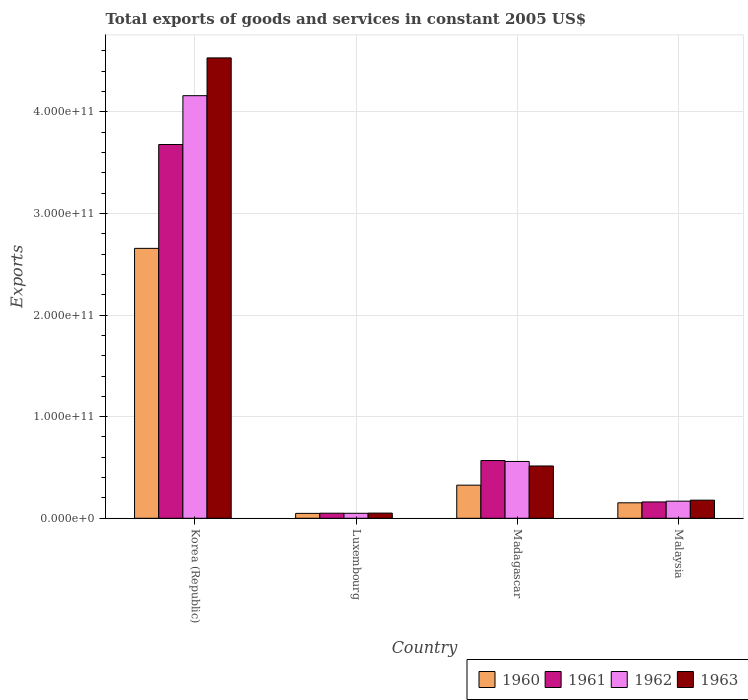How many groups of bars are there?
Provide a short and direct response. 4. Are the number of bars per tick equal to the number of legend labels?
Ensure brevity in your answer.  Yes. How many bars are there on the 1st tick from the right?
Keep it short and to the point. 4. In how many cases, is the number of bars for a given country not equal to the number of legend labels?
Give a very brief answer. 0. What is the total exports of goods and services in 1963 in Malaysia?
Provide a succinct answer. 1.78e+1. Across all countries, what is the maximum total exports of goods and services in 1961?
Make the answer very short. 3.68e+11. Across all countries, what is the minimum total exports of goods and services in 1962?
Ensure brevity in your answer.  4.90e+09. In which country was the total exports of goods and services in 1963 maximum?
Offer a very short reply. Korea (Republic). In which country was the total exports of goods and services in 1963 minimum?
Give a very brief answer. Luxembourg. What is the total total exports of goods and services in 1961 in the graph?
Your answer should be very brief. 4.46e+11. What is the difference between the total exports of goods and services in 1963 in Korea (Republic) and that in Madagascar?
Provide a short and direct response. 4.02e+11. What is the difference between the total exports of goods and services in 1961 in Madagascar and the total exports of goods and services in 1963 in Malaysia?
Keep it short and to the point. 3.90e+1. What is the average total exports of goods and services in 1963 per country?
Ensure brevity in your answer.  1.32e+11. What is the difference between the total exports of goods and services of/in 1962 and total exports of goods and services of/in 1960 in Luxembourg?
Provide a succinct answer. 8.82e+07. What is the ratio of the total exports of goods and services in 1963 in Korea (Republic) to that in Madagascar?
Offer a very short reply. 8.8. Is the total exports of goods and services in 1963 in Madagascar less than that in Malaysia?
Make the answer very short. No. Is the difference between the total exports of goods and services in 1962 in Madagascar and Malaysia greater than the difference between the total exports of goods and services in 1960 in Madagascar and Malaysia?
Your answer should be compact. Yes. What is the difference between the highest and the second highest total exports of goods and services in 1960?
Give a very brief answer. 2.50e+11. What is the difference between the highest and the lowest total exports of goods and services in 1961?
Make the answer very short. 3.63e+11. In how many countries, is the total exports of goods and services in 1960 greater than the average total exports of goods and services in 1960 taken over all countries?
Offer a very short reply. 1. Is the sum of the total exports of goods and services in 1962 in Madagascar and Malaysia greater than the maximum total exports of goods and services in 1963 across all countries?
Give a very brief answer. No. Is it the case that in every country, the sum of the total exports of goods and services in 1960 and total exports of goods and services in 1961 is greater than the sum of total exports of goods and services in 1963 and total exports of goods and services in 1962?
Make the answer very short. No. What does the 4th bar from the left in Luxembourg represents?
Provide a short and direct response. 1963. Are all the bars in the graph horizontal?
Provide a succinct answer. No. What is the difference between two consecutive major ticks on the Y-axis?
Offer a terse response. 1.00e+11. Does the graph contain any zero values?
Give a very brief answer. No. Does the graph contain grids?
Provide a succinct answer. Yes. What is the title of the graph?
Offer a terse response. Total exports of goods and services in constant 2005 US$. What is the label or title of the X-axis?
Your response must be concise. Country. What is the label or title of the Y-axis?
Keep it short and to the point. Exports. What is the Exports of 1960 in Korea (Republic)?
Your response must be concise. 2.66e+11. What is the Exports of 1961 in Korea (Republic)?
Offer a very short reply. 3.68e+11. What is the Exports in 1962 in Korea (Republic)?
Provide a short and direct response. 4.16e+11. What is the Exports of 1963 in Korea (Republic)?
Ensure brevity in your answer.  4.53e+11. What is the Exports of 1960 in Luxembourg?
Ensure brevity in your answer.  4.81e+09. What is the Exports of 1961 in Luxembourg?
Your answer should be very brief. 4.98e+09. What is the Exports of 1962 in Luxembourg?
Give a very brief answer. 4.90e+09. What is the Exports in 1963 in Luxembourg?
Offer a terse response. 5.08e+09. What is the Exports in 1960 in Madagascar?
Provide a succinct answer. 3.26e+1. What is the Exports in 1961 in Madagascar?
Make the answer very short. 5.68e+1. What is the Exports in 1962 in Madagascar?
Ensure brevity in your answer.  5.59e+1. What is the Exports of 1963 in Madagascar?
Ensure brevity in your answer.  5.15e+1. What is the Exports of 1960 in Malaysia?
Ensure brevity in your answer.  1.52e+1. What is the Exports of 1961 in Malaysia?
Provide a short and direct response. 1.61e+1. What is the Exports of 1962 in Malaysia?
Your response must be concise. 1.68e+1. What is the Exports of 1963 in Malaysia?
Make the answer very short. 1.78e+1. Across all countries, what is the maximum Exports in 1960?
Ensure brevity in your answer.  2.66e+11. Across all countries, what is the maximum Exports of 1961?
Your response must be concise. 3.68e+11. Across all countries, what is the maximum Exports of 1962?
Give a very brief answer. 4.16e+11. Across all countries, what is the maximum Exports in 1963?
Offer a terse response. 4.53e+11. Across all countries, what is the minimum Exports in 1960?
Make the answer very short. 4.81e+09. Across all countries, what is the minimum Exports in 1961?
Your answer should be compact. 4.98e+09. Across all countries, what is the minimum Exports in 1962?
Keep it short and to the point. 4.90e+09. Across all countries, what is the minimum Exports in 1963?
Provide a short and direct response. 5.08e+09. What is the total Exports in 1960 in the graph?
Your answer should be very brief. 3.18e+11. What is the total Exports of 1961 in the graph?
Your answer should be compact. 4.46e+11. What is the total Exports of 1962 in the graph?
Make the answer very short. 4.93e+11. What is the total Exports of 1963 in the graph?
Offer a very short reply. 5.27e+11. What is the difference between the Exports in 1960 in Korea (Republic) and that in Luxembourg?
Your response must be concise. 2.61e+11. What is the difference between the Exports of 1961 in Korea (Republic) and that in Luxembourg?
Your response must be concise. 3.63e+11. What is the difference between the Exports of 1962 in Korea (Republic) and that in Luxembourg?
Provide a succinct answer. 4.11e+11. What is the difference between the Exports of 1963 in Korea (Republic) and that in Luxembourg?
Offer a very short reply. 4.48e+11. What is the difference between the Exports in 1960 in Korea (Republic) and that in Madagascar?
Your response must be concise. 2.33e+11. What is the difference between the Exports of 1961 in Korea (Republic) and that in Madagascar?
Offer a terse response. 3.11e+11. What is the difference between the Exports in 1962 in Korea (Republic) and that in Madagascar?
Keep it short and to the point. 3.60e+11. What is the difference between the Exports in 1963 in Korea (Republic) and that in Madagascar?
Give a very brief answer. 4.02e+11. What is the difference between the Exports in 1960 in Korea (Republic) and that in Malaysia?
Give a very brief answer. 2.50e+11. What is the difference between the Exports of 1961 in Korea (Republic) and that in Malaysia?
Your answer should be very brief. 3.52e+11. What is the difference between the Exports of 1962 in Korea (Republic) and that in Malaysia?
Your response must be concise. 3.99e+11. What is the difference between the Exports of 1963 in Korea (Republic) and that in Malaysia?
Give a very brief answer. 4.35e+11. What is the difference between the Exports in 1960 in Luxembourg and that in Madagascar?
Keep it short and to the point. -2.78e+1. What is the difference between the Exports in 1961 in Luxembourg and that in Madagascar?
Your response must be concise. -5.18e+1. What is the difference between the Exports in 1962 in Luxembourg and that in Madagascar?
Give a very brief answer. -5.10e+1. What is the difference between the Exports in 1963 in Luxembourg and that in Madagascar?
Keep it short and to the point. -4.64e+1. What is the difference between the Exports in 1960 in Luxembourg and that in Malaysia?
Provide a succinct answer. -1.04e+1. What is the difference between the Exports of 1961 in Luxembourg and that in Malaysia?
Offer a terse response. -1.11e+1. What is the difference between the Exports in 1962 in Luxembourg and that in Malaysia?
Your answer should be compact. -1.19e+1. What is the difference between the Exports of 1963 in Luxembourg and that in Malaysia?
Ensure brevity in your answer.  -1.27e+1. What is the difference between the Exports in 1960 in Madagascar and that in Malaysia?
Your answer should be compact. 1.74e+1. What is the difference between the Exports in 1961 in Madagascar and that in Malaysia?
Give a very brief answer. 4.07e+1. What is the difference between the Exports in 1962 in Madagascar and that in Malaysia?
Give a very brief answer. 3.91e+1. What is the difference between the Exports in 1963 in Madagascar and that in Malaysia?
Keep it short and to the point. 3.36e+1. What is the difference between the Exports of 1960 in Korea (Republic) and the Exports of 1961 in Luxembourg?
Your answer should be compact. 2.61e+11. What is the difference between the Exports of 1960 in Korea (Republic) and the Exports of 1962 in Luxembourg?
Your response must be concise. 2.61e+11. What is the difference between the Exports in 1960 in Korea (Republic) and the Exports in 1963 in Luxembourg?
Offer a very short reply. 2.61e+11. What is the difference between the Exports of 1961 in Korea (Republic) and the Exports of 1962 in Luxembourg?
Your answer should be very brief. 3.63e+11. What is the difference between the Exports in 1961 in Korea (Republic) and the Exports in 1963 in Luxembourg?
Offer a terse response. 3.63e+11. What is the difference between the Exports in 1962 in Korea (Republic) and the Exports in 1963 in Luxembourg?
Make the answer very short. 4.11e+11. What is the difference between the Exports in 1960 in Korea (Republic) and the Exports in 1961 in Madagascar?
Your response must be concise. 2.09e+11. What is the difference between the Exports in 1960 in Korea (Republic) and the Exports in 1962 in Madagascar?
Your answer should be very brief. 2.10e+11. What is the difference between the Exports of 1960 in Korea (Republic) and the Exports of 1963 in Madagascar?
Your answer should be compact. 2.14e+11. What is the difference between the Exports in 1961 in Korea (Republic) and the Exports in 1962 in Madagascar?
Give a very brief answer. 3.12e+11. What is the difference between the Exports of 1961 in Korea (Republic) and the Exports of 1963 in Madagascar?
Provide a short and direct response. 3.16e+11. What is the difference between the Exports in 1962 in Korea (Republic) and the Exports in 1963 in Madagascar?
Ensure brevity in your answer.  3.64e+11. What is the difference between the Exports of 1960 in Korea (Republic) and the Exports of 1961 in Malaysia?
Provide a short and direct response. 2.50e+11. What is the difference between the Exports of 1960 in Korea (Republic) and the Exports of 1962 in Malaysia?
Your answer should be compact. 2.49e+11. What is the difference between the Exports of 1960 in Korea (Republic) and the Exports of 1963 in Malaysia?
Your response must be concise. 2.48e+11. What is the difference between the Exports of 1961 in Korea (Republic) and the Exports of 1962 in Malaysia?
Offer a very short reply. 3.51e+11. What is the difference between the Exports in 1961 in Korea (Republic) and the Exports in 1963 in Malaysia?
Your answer should be compact. 3.50e+11. What is the difference between the Exports of 1962 in Korea (Republic) and the Exports of 1963 in Malaysia?
Make the answer very short. 3.98e+11. What is the difference between the Exports of 1960 in Luxembourg and the Exports of 1961 in Madagascar?
Provide a short and direct response. -5.20e+1. What is the difference between the Exports in 1960 in Luxembourg and the Exports in 1962 in Madagascar?
Your answer should be very brief. -5.11e+1. What is the difference between the Exports in 1960 in Luxembourg and the Exports in 1963 in Madagascar?
Your answer should be compact. -4.67e+1. What is the difference between the Exports of 1961 in Luxembourg and the Exports of 1962 in Madagascar?
Your answer should be compact. -5.09e+1. What is the difference between the Exports of 1961 in Luxembourg and the Exports of 1963 in Madagascar?
Your response must be concise. -4.65e+1. What is the difference between the Exports of 1962 in Luxembourg and the Exports of 1963 in Madagascar?
Provide a short and direct response. -4.66e+1. What is the difference between the Exports of 1960 in Luxembourg and the Exports of 1961 in Malaysia?
Give a very brief answer. -1.13e+1. What is the difference between the Exports of 1960 in Luxembourg and the Exports of 1962 in Malaysia?
Make the answer very short. -1.20e+1. What is the difference between the Exports of 1960 in Luxembourg and the Exports of 1963 in Malaysia?
Offer a terse response. -1.30e+1. What is the difference between the Exports in 1961 in Luxembourg and the Exports in 1962 in Malaysia?
Offer a very short reply. -1.19e+1. What is the difference between the Exports of 1961 in Luxembourg and the Exports of 1963 in Malaysia?
Give a very brief answer. -1.28e+1. What is the difference between the Exports in 1962 in Luxembourg and the Exports in 1963 in Malaysia?
Offer a terse response. -1.29e+1. What is the difference between the Exports of 1960 in Madagascar and the Exports of 1961 in Malaysia?
Give a very brief answer. 1.65e+1. What is the difference between the Exports in 1960 in Madagascar and the Exports in 1962 in Malaysia?
Offer a terse response. 1.57e+1. What is the difference between the Exports in 1960 in Madagascar and the Exports in 1963 in Malaysia?
Your response must be concise. 1.48e+1. What is the difference between the Exports in 1961 in Madagascar and the Exports in 1962 in Malaysia?
Provide a short and direct response. 4.00e+1. What is the difference between the Exports in 1961 in Madagascar and the Exports in 1963 in Malaysia?
Make the answer very short. 3.90e+1. What is the difference between the Exports of 1962 in Madagascar and the Exports of 1963 in Malaysia?
Provide a succinct answer. 3.81e+1. What is the average Exports of 1960 per country?
Offer a very short reply. 7.96e+1. What is the average Exports in 1961 per country?
Your answer should be compact. 1.11e+11. What is the average Exports of 1962 per country?
Offer a terse response. 1.23e+11. What is the average Exports in 1963 per country?
Offer a terse response. 1.32e+11. What is the difference between the Exports in 1960 and Exports in 1961 in Korea (Republic)?
Offer a very short reply. -1.02e+11. What is the difference between the Exports of 1960 and Exports of 1962 in Korea (Republic)?
Give a very brief answer. -1.50e+11. What is the difference between the Exports of 1960 and Exports of 1963 in Korea (Republic)?
Keep it short and to the point. -1.87e+11. What is the difference between the Exports in 1961 and Exports in 1962 in Korea (Republic)?
Your answer should be compact. -4.81e+1. What is the difference between the Exports in 1961 and Exports in 1963 in Korea (Republic)?
Give a very brief answer. -8.52e+1. What is the difference between the Exports in 1962 and Exports in 1963 in Korea (Republic)?
Keep it short and to the point. -3.72e+1. What is the difference between the Exports of 1960 and Exports of 1961 in Luxembourg?
Provide a succinct answer. -1.68e+08. What is the difference between the Exports in 1960 and Exports in 1962 in Luxembourg?
Give a very brief answer. -8.82e+07. What is the difference between the Exports in 1960 and Exports in 1963 in Luxembourg?
Ensure brevity in your answer.  -2.73e+08. What is the difference between the Exports in 1961 and Exports in 1962 in Luxembourg?
Provide a short and direct response. 7.94e+07. What is the difference between the Exports in 1961 and Exports in 1963 in Luxembourg?
Ensure brevity in your answer.  -1.05e+08. What is the difference between the Exports of 1962 and Exports of 1963 in Luxembourg?
Provide a short and direct response. -1.85e+08. What is the difference between the Exports of 1960 and Exports of 1961 in Madagascar?
Your answer should be very brief. -2.42e+1. What is the difference between the Exports in 1960 and Exports in 1962 in Madagascar?
Offer a terse response. -2.33e+1. What is the difference between the Exports of 1960 and Exports of 1963 in Madagascar?
Keep it short and to the point. -1.89e+1. What is the difference between the Exports in 1961 and Exports in 1962 in Madagascar?
Your response must be concise. 8.87e+08. What is the difference between the Exports in 1961 and Exports in 1963 in Madagascar?
Your response must be concise. 5.32e+09. What is the difference between the Exports in 1962 and Exports in 1963 in Madagascar?
Provide a succinct answer. 4.44e+09. What is the difference between the Exports of 1960 and Exports of 1961 in Malaysia?
Offer a terse response. -8.42e+08. What is the difference between the Exports in 1960 and Exports in 1962 in Malaysia?
Give a very brief answer. -1.61e+09. What is the difference between the Exports in 1960 and Exports in 1963 in Malaysia?
Provide a short and direct response. -2.60e+09. What is the difference between the Exports in 1961 and Exports in 1962 in Malaysia?
Ensure brevity in your answer.  -7.72e+08. What is the difference between the Exports in 1961 and Exports in 1963 in Malaysia?
Offer a terse response. -1.76e+09. What is the difference between the Exports of 1962 and Exports of 1963 in Malaysia?
Give a very brief answer. -9.85e+08. What is the ratio of the Exports of 1960 in Korea (Republic) to that in Luxembourg?
Your answer should be compact. 55.23. What is the ratio of the Exports of 1961 in Korea (Republic) to that in Luxembourg?
Make the answer very short. 73.91. What is the ratio of the Exports in 1962 in Korea (Republic) to that in Luxembourg?
Offer a very short reply. 84.92. What is the ratio of the Exports in 1963 in Korea (Republic) to that in Luxembourg?
Offer a very short reply. 89.15. What is the ratio of the Exports of 1960 in Korea (Republic) to that in Madagascar?
Offer a very short reply. 8.15. What is the ratio of the Exports of 1961 in Korea (Republic) to that in Madagascar?
Provide a short and direct response. 6.48. What is the ratio of the Exports of 1962 in Korea (Republic) to that in Madagascar?
Your response must be concise. 7.44. What is the ratio of the Exports of 1963 in Korea (Republic) to that in Madagascar?
Your answer should be compact. 8.8. What is the ratio of the Exports in 1960 in Korea (Republic) to that in Malaysia?
Give a very brief answer. 17.45. What is the ratio of the Exports in 1961 in Korea (Republic) to that in Malaysia?
Your answer should be very brief. 22.9. What is the ratio of the Exports of 1962 in Korea (Republic) to that in Malaysia?
Your answer should be compact. 24.7. What is the ratio of the Exports in 1963 in Korea (Republic) to that in Malaysia?
Ensure brevity in your answer.  25.42. What is the ratio of the Exports in 1960 in Luxembourg to that in Madagascar?
Make the answer very short. 0.15. What is the ratio of the Exports in 1961 in Luxembourg to that in Madagascar?
Your response must be concise. 0.09. What is the ratio of the Exports of 1962 in Luxembourg to that in Madagascar?
Offer a very short reply. 0.09. What is the ratio of the Exports of 1963 in Luxembourg to that in Madagascar?
Your answer should be very brief. 0.1. What is the ratio of the Exports of 1960 in Luxembourg to that in Malaysia?
Your answer should be very brief. 0.32. What is the ratio of the Exports of 1961 in Luxembourg to that in Malaysia?
Provide a short and direct response. 0.31. What is the ratio of the Exports of 1962 in Luxembourg to that in Malaysia?
Ensure brevity in your answer.  0.29. What is the ratio of the Exports of 1963 in Luxembourg to that in Malaysia?
Give a very brief answer. 0.29. What is the ratio of the Exports in 1960 in Madagascar to that in Malaysia?
Make the answer very short. 2.14. What is the ratio of the Exports in 1961 in Madagascar to that in Malaysia?
Your answer should be compact. 3.54. What is the ratio of the Exports of 1962 in Madagascar to that in Malaysia?
Offer a terse response. 3.32. What is the ratio of the Exports of 1963 in Madagascar to that in Malaysia?
Offer a very short reply. 2.89. What is the difference between the highest and the second highest Exports of 1960?
Offer a very short reply. 2.33e+11. What is the difference between the highest and the second highest Exports in 1961?
Offer a terse response. 3.11e+11. What is the difference between the highest and the second highest Exports of 1962?
Your answer should be compact. 3.60e+11. What is the difference between the highest and the second highest Exports in 1963?
Your answer should be very brief. 4.02e+11. What is the difference between the highest and the lowest Exports of 1960?
Provide a succinct answer. 2.61e+11. What is the difference between the highest and the lowest Exports of 1961?
Offer a very short reply. 3.63e+11. What is the difference between the highest and the lowest Exports in 1962?
Provide a succinct answer. 4.11e+11. What is the difference between the highest and the lowest Exports of 1963?
Ensure brevity in your answer.  4.48e+11. 